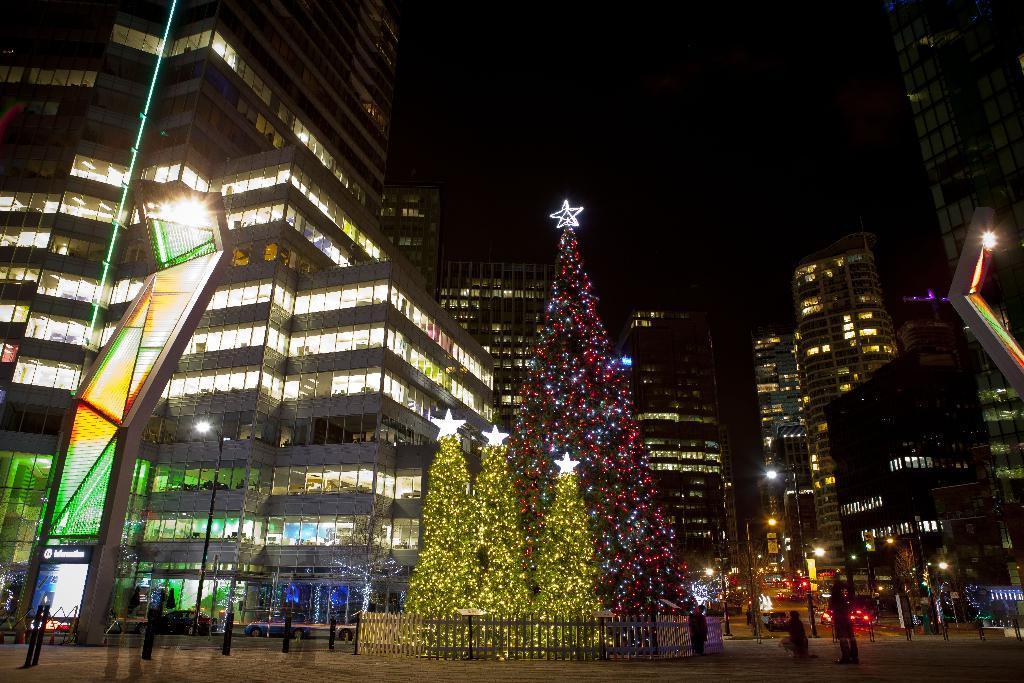Describe this image in one or two sentences. In the foreground of the image we can see Christmas tree with lighting on it. Group of persons are standing on the road. In the background there are several buildings and sky. 